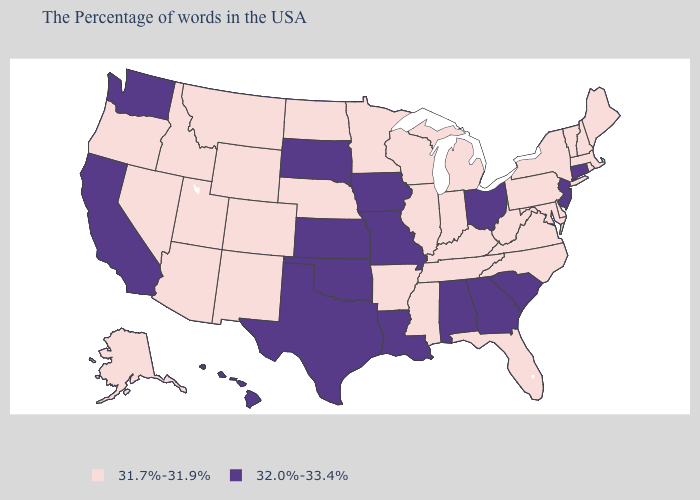Name the states that have a value in the range 32.0%-33.4%?
Give a very brief answer. Connecticut, New Jersey, South Carolina, Ohio, Georgia, Alabama, Louisiana, Missouri, Iowa, Kansas, Oklahoma, Texas, South Dakota, California, Washington, Hawaii. Name the states that have a value in the range 31.7%-31.9%?
Short answer required. Maine, Massachusetts, Rhode Island, New Hampshire, Vermont, New York, Delaware, Maryland, Pennsylvania, Virginia, North Carolina, West Virginia, Florida, Michigan, Kentucky, Indiana, Tennessee, Wisconsin, Illinois, Mississippi, Arkansas, Minnesota, Nebraska, North Dakota, Wyoming, Colorado, New Mexico, Utah, Montana, Arizona, Idaho, Nevada, Oregon, Alaska. Name the states that have a value in the range 31.7%-31.9%?
Write a very short answer. Maine, Massachusetts, Rhode Island, New Hampshire, Vermont, New York, Delaware, Maryland, Pennsylvania, Virginia, North Carolina, West Virginia, Florida, Michigan, Kentucky, Indiana, Tennessee, Wisconsin, Illinois, Mississippi, Arkansas, Minnesota, Nebraska, North Dakota, Wyoming, Colorado, New Mexico, Utah, Montana, Arizona, Idaho, Nevada, Oregon, Alaska. Does the first symbol in the legend represent the smallest category?
Concise answer only. Yes. Which states have the lowest value in the Northeast?
Concise answer only. Maine, Massachusetts, Rhode Island, New Hampshire, Vermont, New York, Pennsylvania. What is the value of South Carolina?
Be succinct. 32.0%-33.4%. Does Idaho have the highest value in the USA?
Give a very brief answer. No. Does Ohio have the highest value in the MidWest?
Answer briefly. Yes. Name the states that have a value in the range 32.0%-33.4%?
Concise answer only. Connecticut, New Jersey, South Carolina, Ohio, Georgia, Alabama, Louisiana, Missouri, Iowa, Kansas, Oklahoma, Texas, South Dakota, California, Washington, Hawaii. Name the states that have a value in the range 32.0%-33.4%?
Quick response, please. Connecticut, New Jersey, South Carolina, Ohio, Georgia, Alabama, Louisiana, Missouri, Iowa, Kansas, Oklahoma, Texas, South Dakota, California, Washington, Hawaii. Which states have the highest value in the USA?
Concise answer only. Connecticut, New Jersey, South Carolina, Ohio, Georgia, Alabama, Louisiana, Missouri, Iowa, Kansas, Oklahoma, Texas, South Dakota, California, Washington, Hawaii. Name the states that have a value in the range 31.7%-31.9%?
Give a very brief answer. Maine, Massachusetts, Rhode Island, New Hampshire, Vermont, New York, Delaware, Maryland, Pennsylvania, Virginia, North Carolina, West Virginia, Florida, Michigan, Kentucky, Indiana, Tennessee, Wisconsin, Illinois, Mississippi, Arkansas, Minnesota, Nebraska, North Dakota, Wyoming, Colorado, New Mexico, Utah, Montana, Arizona, Idaho, Nevada, Oregon, Alaska. How many symbols are there in the legend?
Give a very brief answer. 2. What is the highest value in the Northeast ?
Answer briefly. 32.0%-33.4%. 